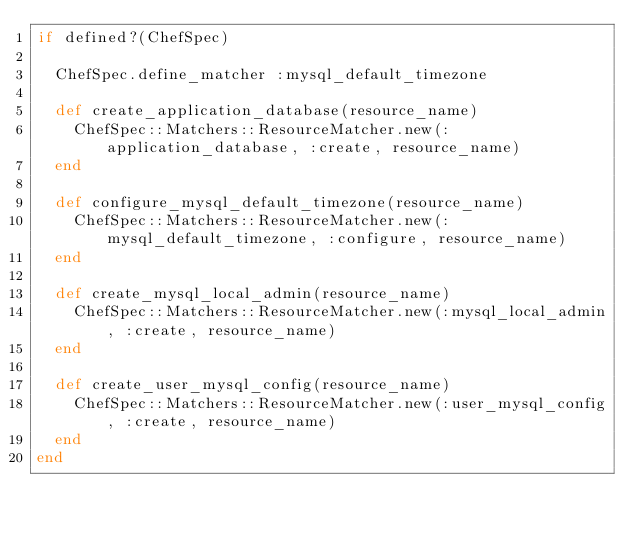Convert code to text. <code><loc_0><loc_0><loc_500><loc_500><_Ruby_>if defined?(ChefSpec)

  ChefSpec.define_matcher :mysql_default_timezone

  def create_application_database(resource_name)
    ChefSpec::Matchers::ResourceMatcher.new(:application_database, :create, resource_name)
  end

  def configure_mysql_default_timezone(resource_name)
    ChefSpec::Matchers::ResourceMatcher.new(:mysql_default_timezone, :configure, resource_name)
  end

  def create_mysql_local_admin(resource_name)
    ChefSpec::Matchers::ResourceMatcher.new(:mysql_local_admin, :create, resource_name)
  end

  def create_user_mysql_config(resource_name)
    ChefSpec::Matchers::ResourceMatcher.new(:user_mysql_config, :create, resource_name)
  end
end
</code> 